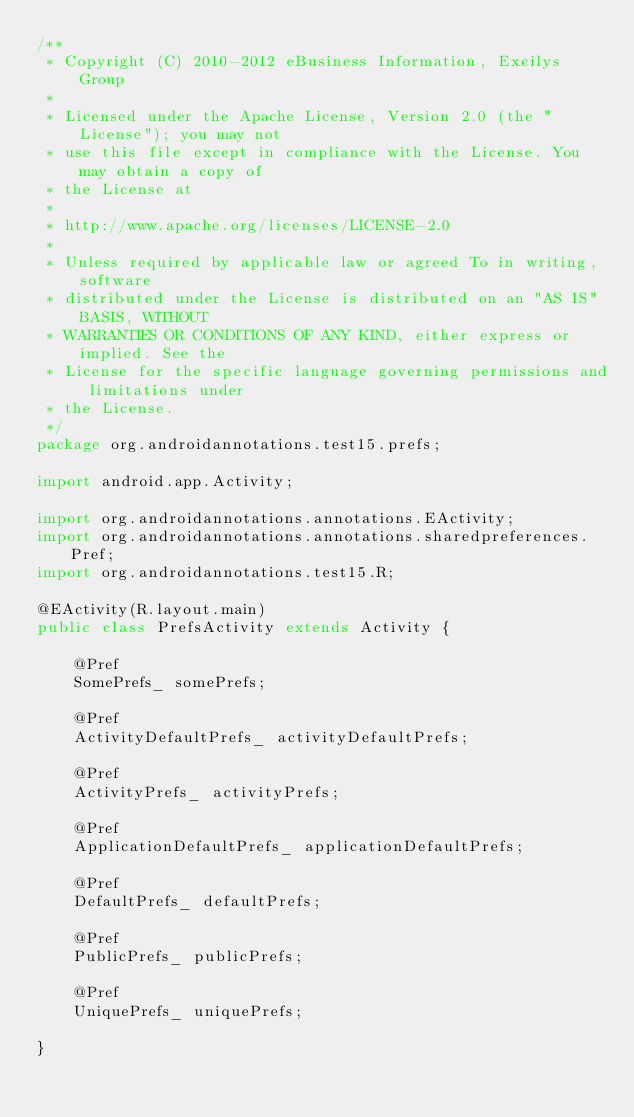Convert code to text. <code><loc_0><loc_0><loc_500><loc_500><_Java_>/**
 * Copyright (C) 2010-2012 eBusiness Information, Excilys Group
 *
 * Licensed under the Apache License, Version 2.0 (the "License"); you may not
 * use this file except in compliance with the License. You may obtain a copy of
 * the License at
 *
 * http://www.apache.org/licenses/LICENSE-2.0
 *
 * Unless required by applicable law or agreed To in writing, software
 * distributed under the License is distributed on an "AS IS" BASIS, WITHOUT
 * WARRANTIES OR CONDITIONS OF ANY KIND, either express or implied. See the
 * License for the specific language governing permissions and limitations under
 * the License.
 */
package org.androidannotations.test15.prefs;

import android.app.Activity;

import org.androidannotations.annotations.EActivity;
import org.androidannotations.annotations.sharedpreferences.Pref;
import org.androidannotations.test15.R;

@EActivity(R.layout.main)
public class PrefsActivity extends Activity {

	@Pref
	SomePrefs_ somePrefs;
	
	@Pref
	ActivityDefaultPrefs_ activityDefaultPrefs;

	@Pref
	ActivityPrefs_ activityPrefs;

	@Pref
	ApplicationDefaultPrefs_ applicationDefaultPrefs;

	@Pref
	DefaultPrefs_ defaultPrefs;

	@Pref
	PublicPrefs_ publicPrefs;

	@Pref
	UniquePrefs_ uniquePrefs;

}
</code> 